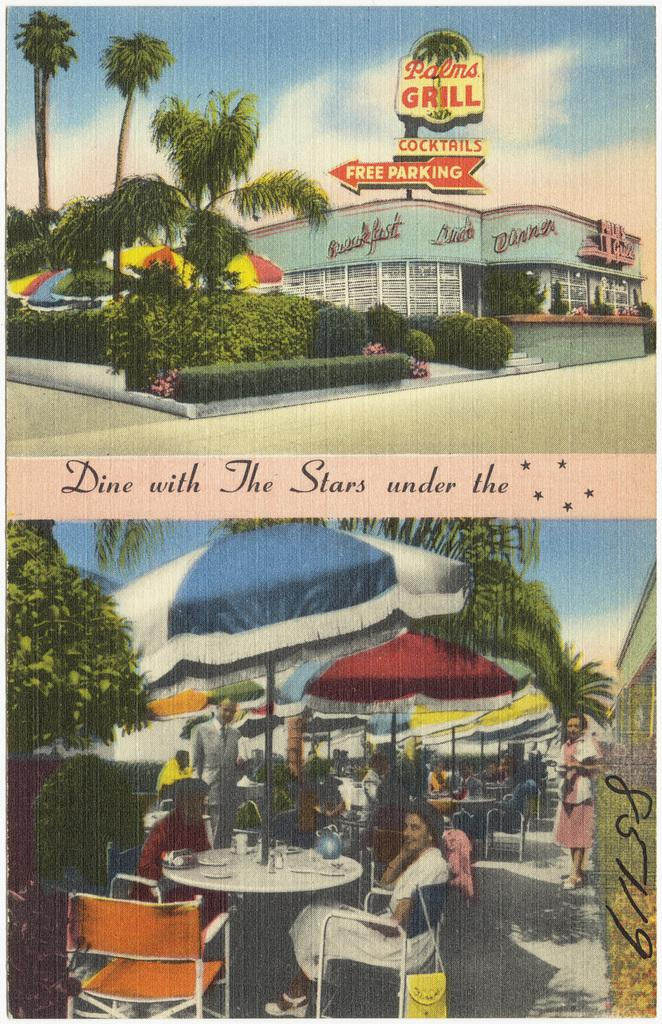What type of establishment is depicted in the image? There is a collage photo of an outdoor restaurant in the image. What are the people in the image doing? There are people sitting at a table in the image. What other structures can be seen in the image? There is a resort building visible in the image. What type of natural environment is present in the image? There are trees in the image. How many balloons are tied to the bike in the image? There is no bike or balloons present in the image. What type of building is shown next to the restaurant in the image? The provided facts do not mention any specific building next to the restaurant; only a resort building is mentioned as visible in the image. 